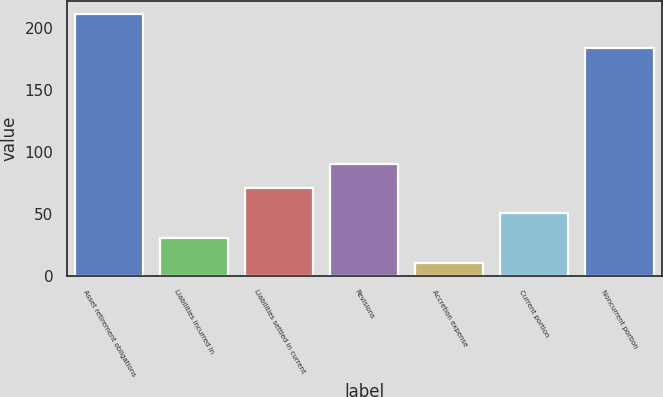<chart> <loc_0><loc_0><loc_500><loc_500><bar_chart><fcel>Asset retirement obligations<fcel>Liabilities incurred in<fcel>Liabilities settled in current<fcel>Revisions<fcel>Accretion expense<fcel>Current portion<fcel>Noncurrent portion<nl><fcel>211<fcel>30.1<fcel>70.3<fcel>90.4<fcel>10<fcel>50.2<fcel>184<nl></chart> 